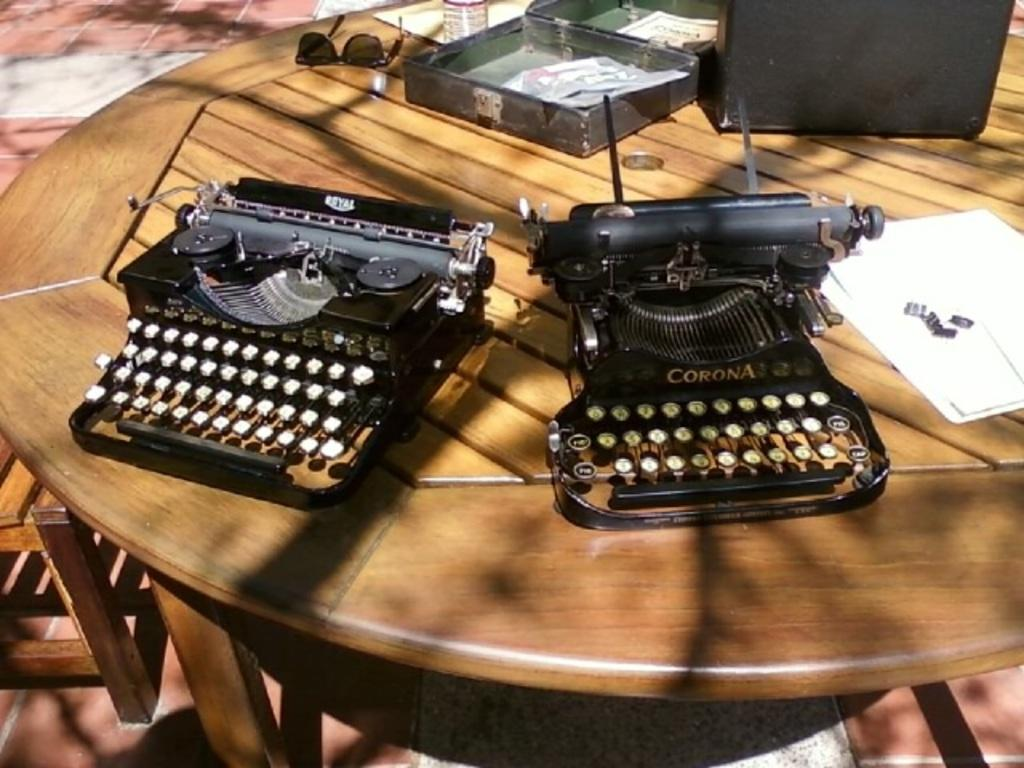<image>
Describe the image concisely. Two Corona branded typewriters sitting on a table under the sunlight. 